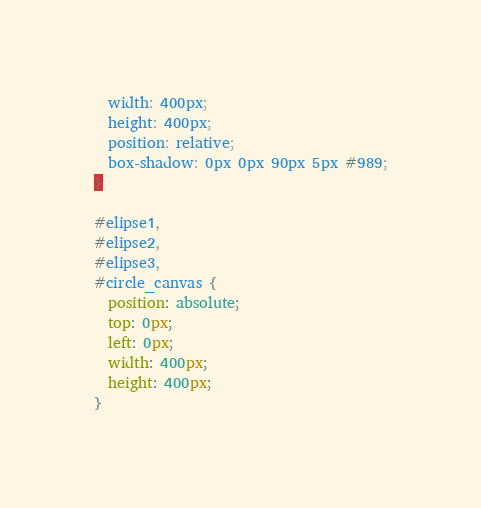<code> <loc_0><loc_0><loc_500><loc_500><_CSS_>  width: 400px;
  height: 400px;
  position: relative;
  box-shadow: 0px 0px 90px 5px #989;
}

#elipse1,
#elipse2,
#elipse3,
#circle_canvas {
  position: absolute;
  top: 0px;
  left: 0px;
  width: 400px;
  height: 400px;
}
</code> 